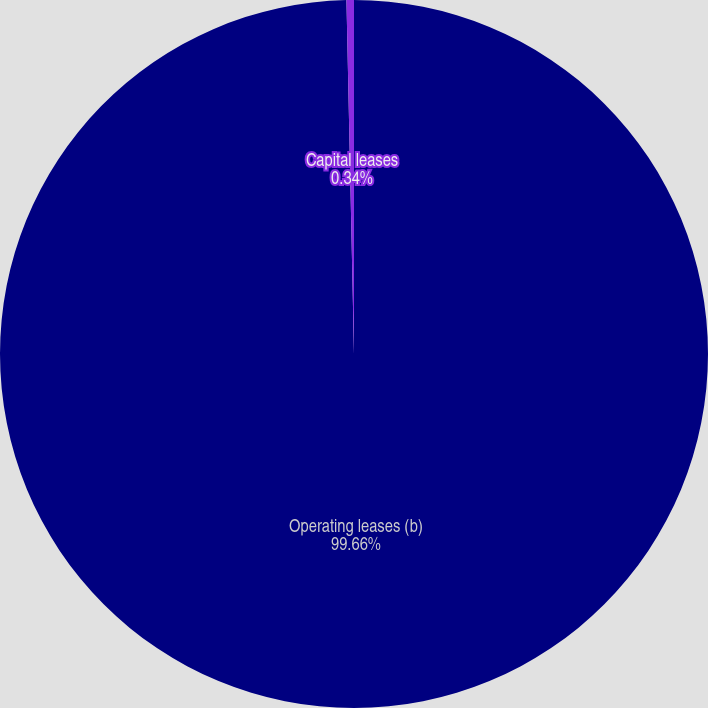Convert chart. <chart><loc_0><loc_0><loc_500><loc_500><pie_chart><fcel>Operating leases (b)<fcel>Capital leases<nl><fcel>99.66%<fcel>0.34%<nl></chart> 